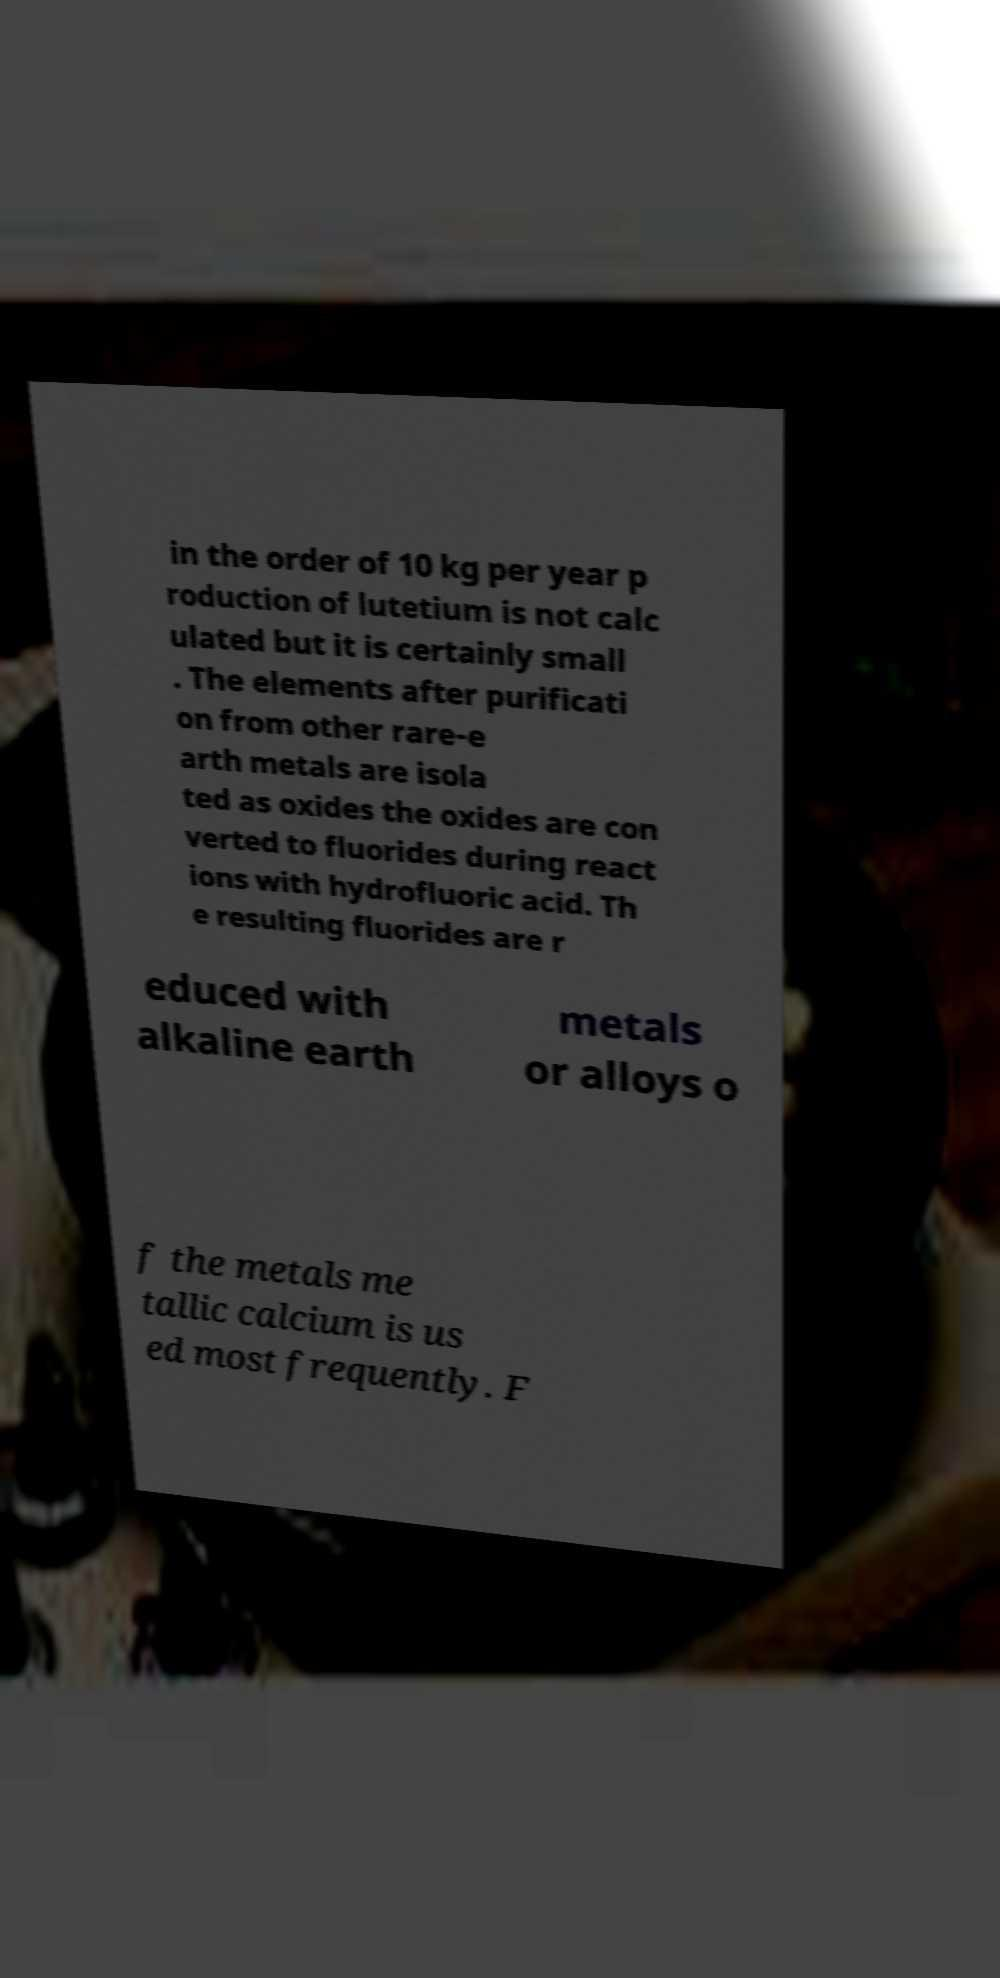For documentation purposes, I need the text within this image transcribed. Could you provide that? in the order of 10 kg per year p roduction of lutetium is not calc ulated but it is certainly small . The elements after purificati on from other rare-e arth metals are isola ted as oxides the oxides are con verted to fluorides during react ions with hydrofluoric acid. Th e resulting fluorides are r educed with alkaline earth metals or alloys o f the metals me tallic calcium is us ed most frequently. F 